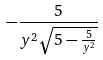<formula> <loc_0><loc_0><loc_500><loc_500>- \frac { 5 } { y ^ { 2 } \sqrt { 5 - \frac { 5 } { y ^ { 2 } } } }</formula> 